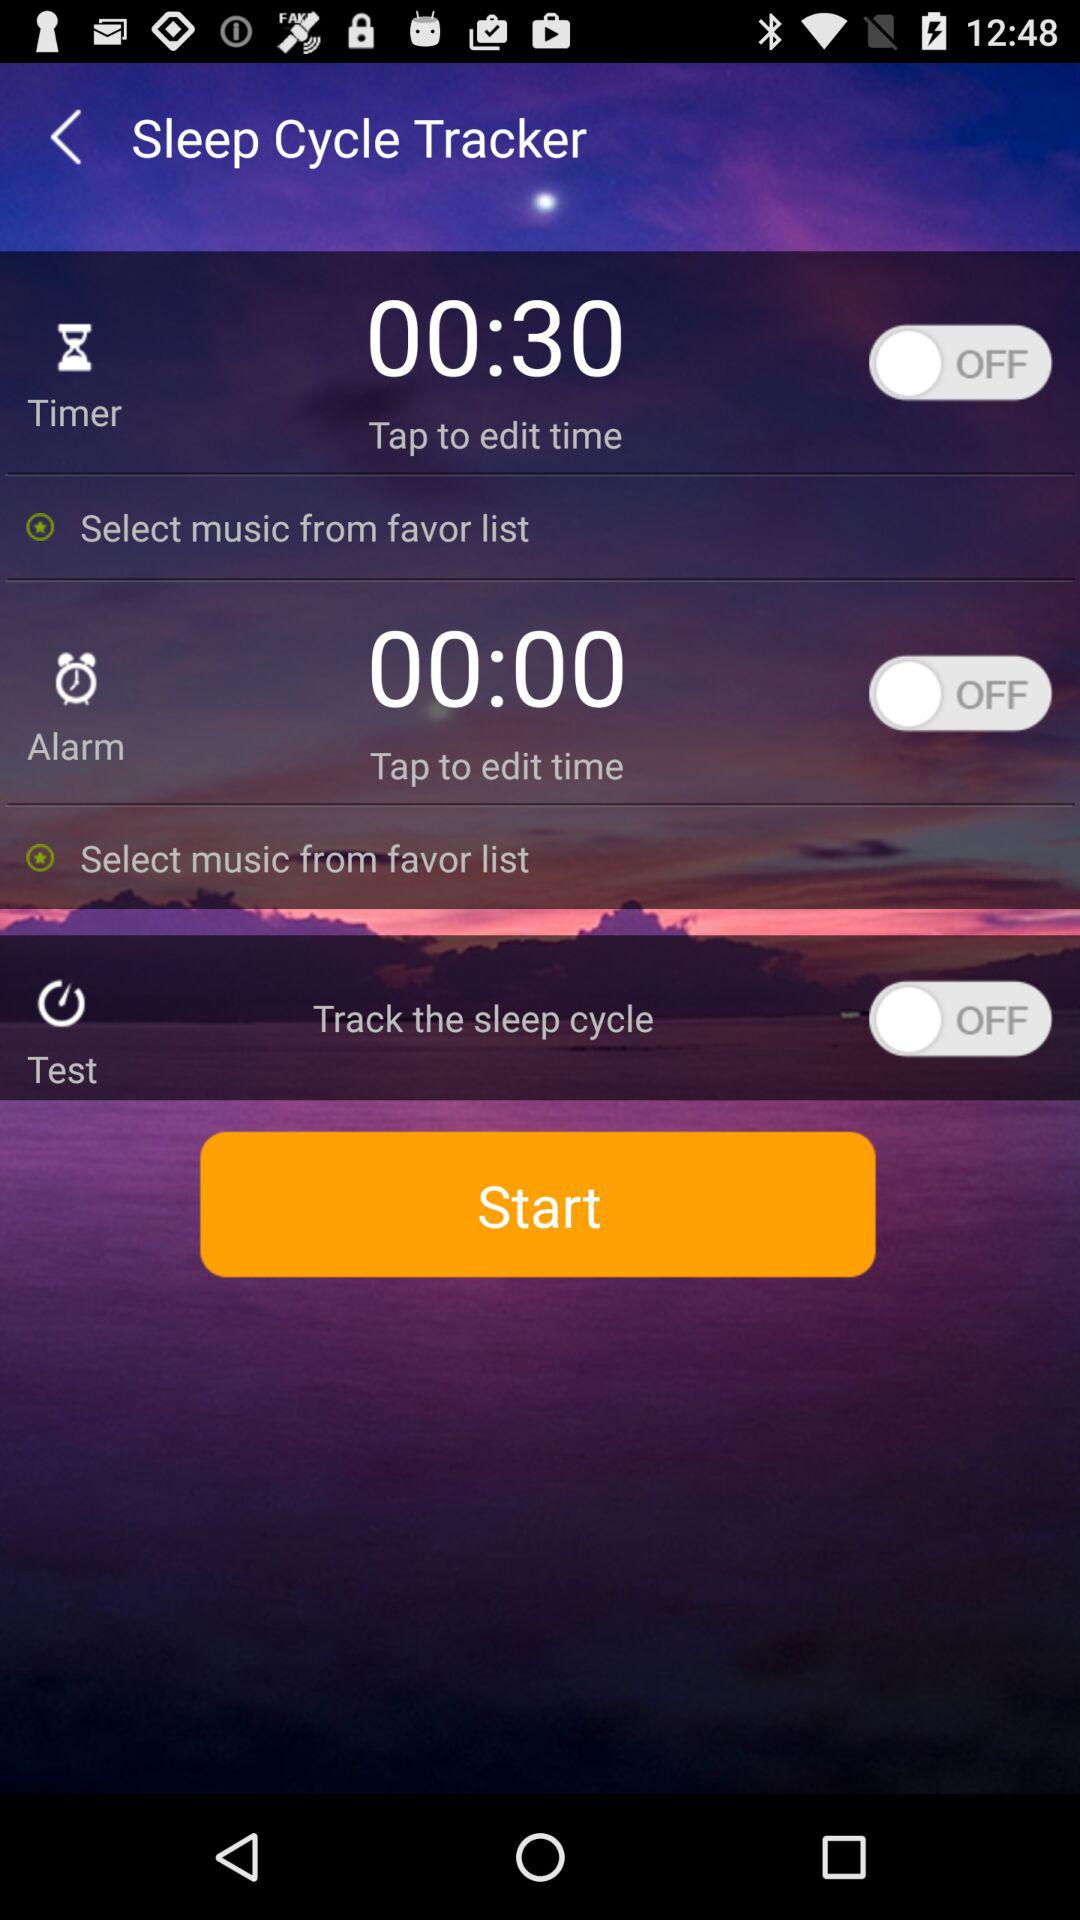What is the name of the application? The name of the application is "Sleep Cycle Tracker". 